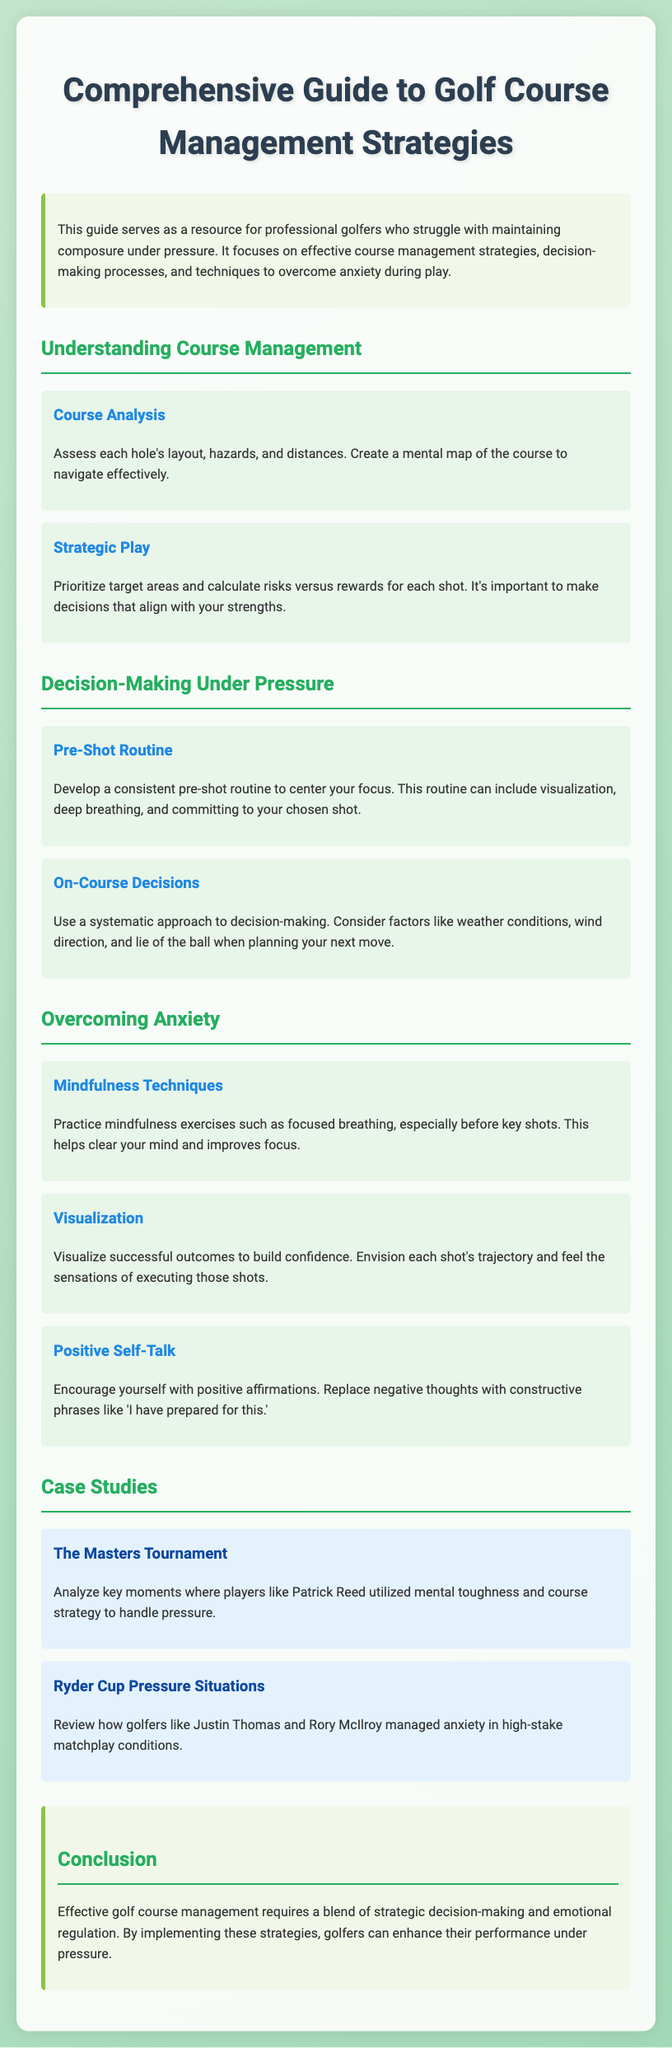What is the main focus of the guide? The guide focuses on effective course management strategies, decision-making processes, and techniques to overcome anxiety during play.
Answer: course management strategies What is one technique mentioned for overcoming anxiety? One technique to overcome anxiety is practicing mindfulness exercises such as focused breathing.
Answer: mindfulness exercises What is emphasized in the section on decision-making under pressure? The section emphasizes developing a consistent pre-shot routine to center your focus.
Answer: consistent pre-shot routine How many case studies are presented in the document? The document presents two case studies related to pressure situations in golf.
Answer: two Who is mentioned as an example in the case studies? Patrick Reed is mentioned as an example in the case studies discussing mental toughness and course strategy.
Answer: Patrick Reed What should players prioritize according to the strategic play section? Players should prioritize target areas and calculate risks versus rewards for each shot.
Answer: target areas What role does visualization play according to the guide? Visualization helps in building confidence and envisions successful outcomes before executing shots.
Answer: building confidence What color is used for the headings in the document? The headings in the document are colored with shades of blue and green.
Answer: blue and green 